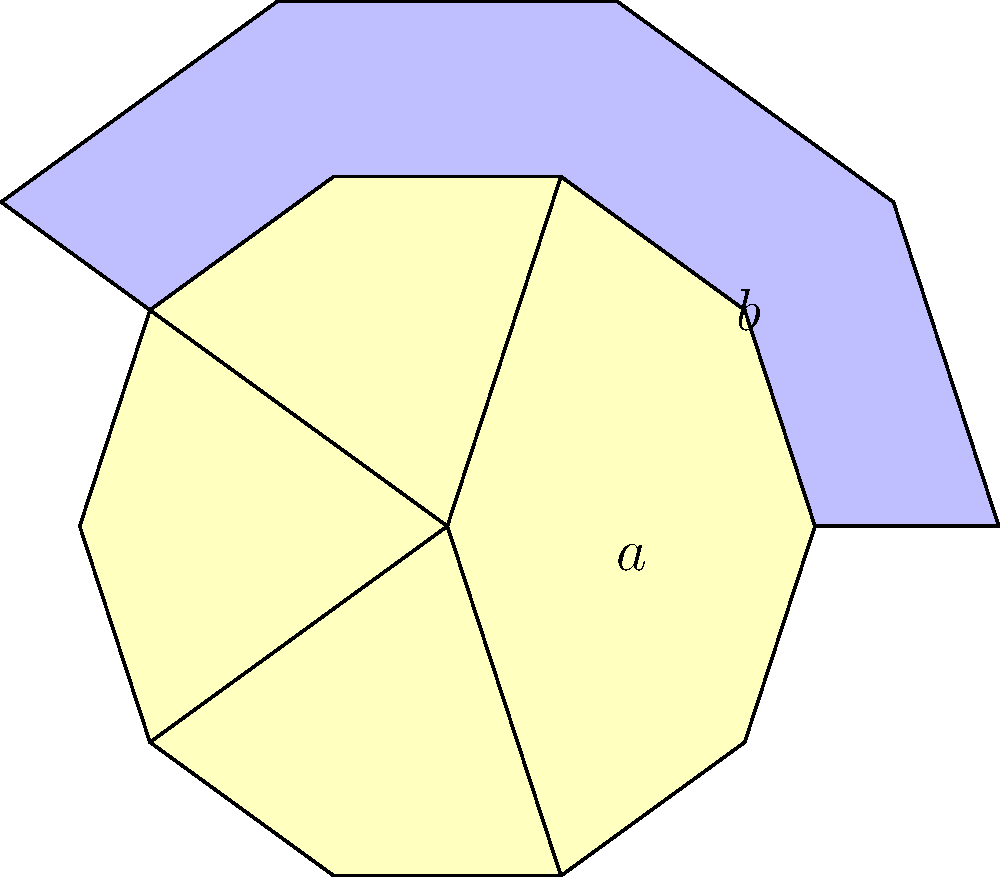In this Islamic geometric pattern, a regular decagon contains five overlapping stars. If the side length of each star is $a$ and the side length of the decagon is $b$, calculate the total area of the yellow star regions in terms of $a$ and $b$. Let's approach this step-by-step:

1) First, we need to calculate the area of a single star:
   - The star is composed of 5 isosceles triangles.
   - The central angle of each triangle is $36^\circ$ (as $360^\circ / 10 = 36^\circ$).
   - The area of one triangle is: $A_t = \frac{1}{2}a^2 \sin 36^\circ$
   - So, the area of the star is: $A_s = 5 \cdot \frac{1}{2}a^2 \sin 36^\circ = \frac{5}{2}a^2 \sin 36^\circ$

2) Now, let's calculate the area of the decagon:
   - The area of a regular decagon with side length $b$ is:
     $A_d = \frac{5}{2}b^2 \sqrt{5+2\sqrt{5}}$

3) The ratio of the star's side length to the decagon's side length is:
   $\frac{a}{b} = \frac{1}{\varphi}$, where $\varphi = \frac{1+\sqrt{5}}{2}$ is the golden ratio.

4) Substituting this into the star's area formula:
   $A_s = \frac{5}{2}(\frac{b}{\varphi})^2 \sin 36^\circ = \frac{5}{2\varphi^2}b^2 \sin 36^\circ$

5) The total area of the yellow regions is the area of 5 stars minus their overlaps.
   The overlaps form another regular decagon in the center, similar to the outer decagon.

6) The ratio of the inner decagon's area to the outer decagon's area is $(\frac{1}{\varphi^2})^2 = \frac{1}{\varphi^4}$

7) Therefore, the total yellow area is:
   $A_{yellow} = 5A_s - \frac{1}{\varphi^4}A_d$

8) Substituting the expressions we derived:
   $A_{yellow} = 5 \cdot \frac{5}{2\varphi^2}b^2 \sin 36^\circ - \frac{1}{\varphi^4} \cdot \frac{5}{2}b^2 \sqrt{5+2\sqrt{5}}$

9) Simplifying:
   $A_{yellow} = \frac{25}{2\varphi^2}b^2 \sin 36^\circ - \frac{5}{2\varphi^4}b^2 \sqrt{5+2\sqrt{5}}$

This is the final expression for the yellow area in terms of $b$.
Answer: $\frac{25}{2\varphi^2}b^2 \sin 36^\circ - \frac{5}{2\varphi^4}b^2 \sqrt{5+2\sqrt{5}}$ 